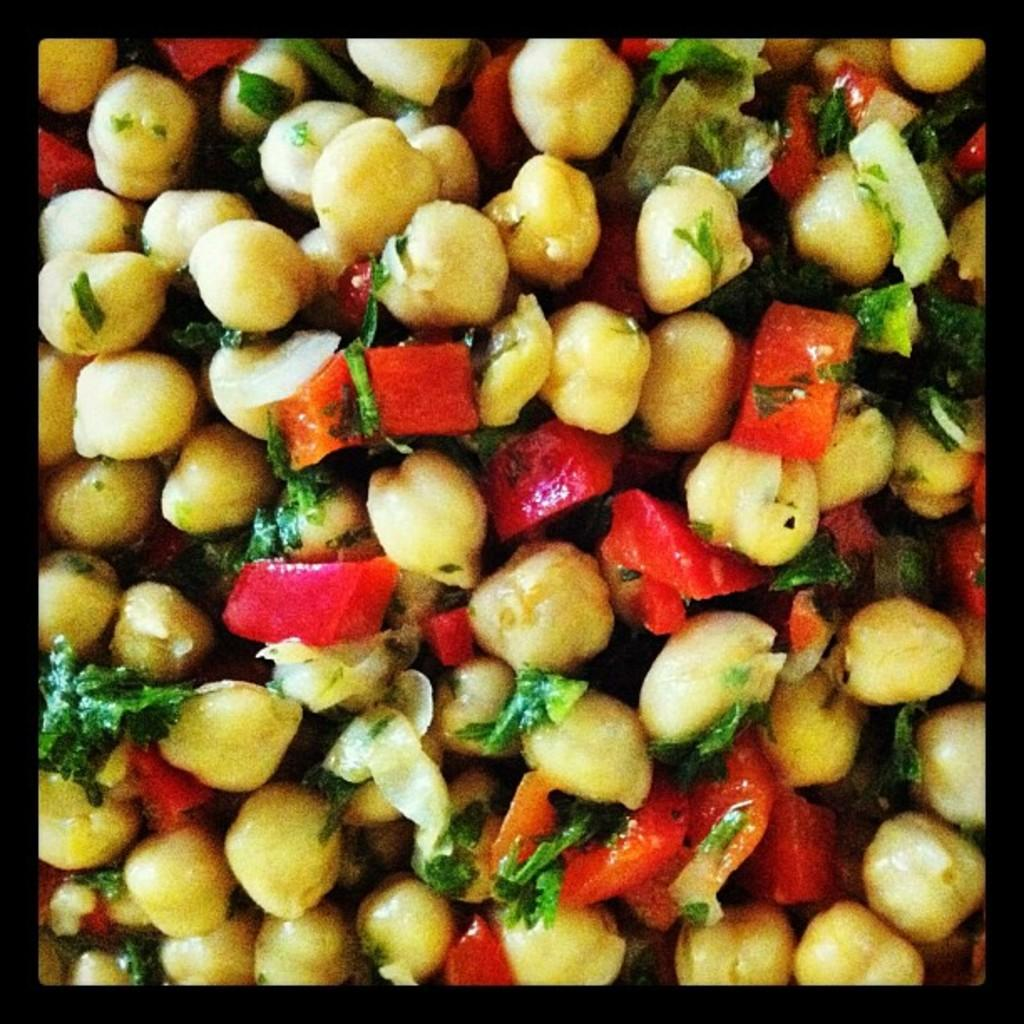What type of food is visible in the image? There are chickpeas, tomatoes, and coriander leaves in the image. What might the combination of these ingredients suggest? The image might depict a chickpea salad, given the presence of chickpeas, tomatoes, and coriander leaves. What type of mine can be seen in the image? There is no mine present in the image; it features chickpeas, tomatoes, and coriander leaves. Can you tell me how the camera is used in the image? There is no camera present in the image; it only shows food ingredients. 